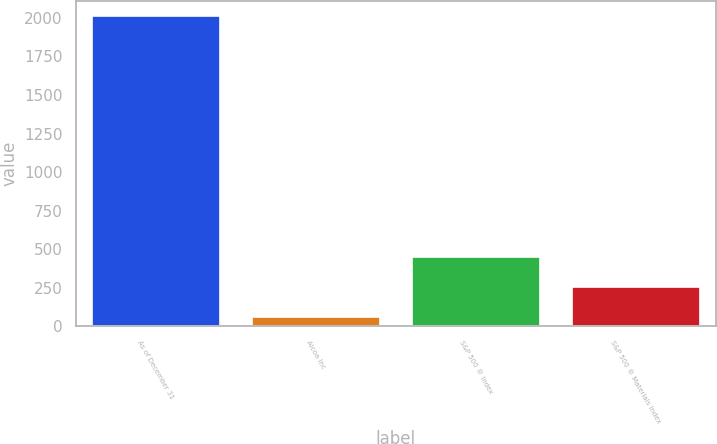Convert chart to OTSL. <chart><loc_0><loc_0><loc_500><loc_500><bar_chart><fcel>As of December 31<fcel>Alcoa Inc<fcel>S&P 500 ® Index<fcel>S&P 500 ® Materials Index<nl><fcel>2012<fcel>58<fcel>448.8<fcel>253.4<nl></chart> 